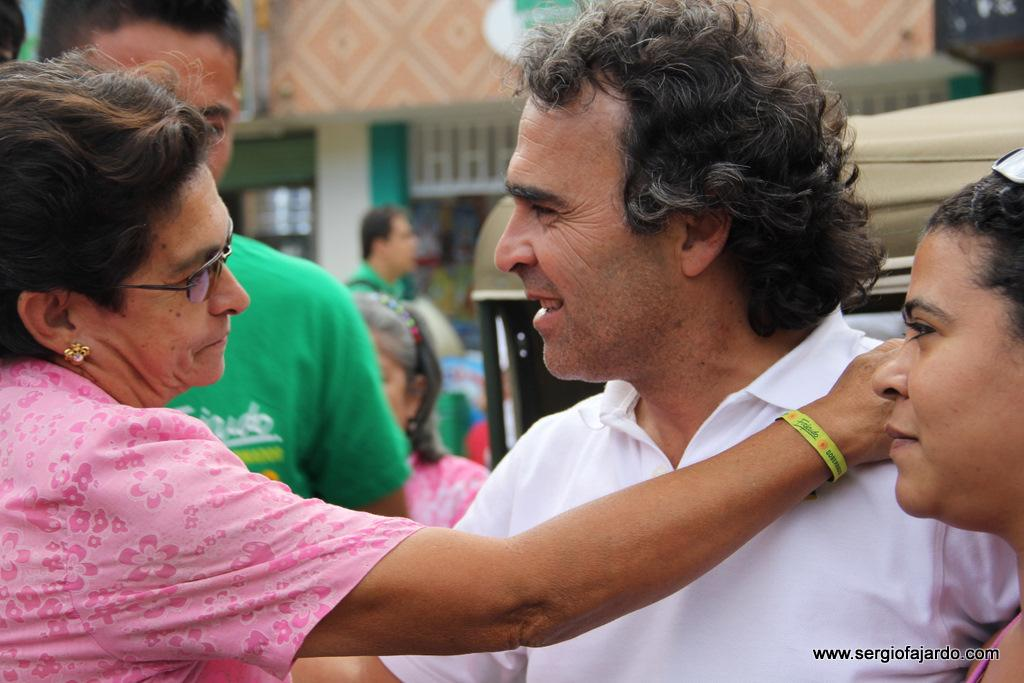What can be seen in the image? There are people standing in the image. What is visible in the background of the image? There is a vehicle and a building in the background of the image. Where is the text located in the image? The text is in the bottom right corner of the image. What is the opinion of the bike in the image? There is no bike present in the image, so it is not possible to determine its opinion. 